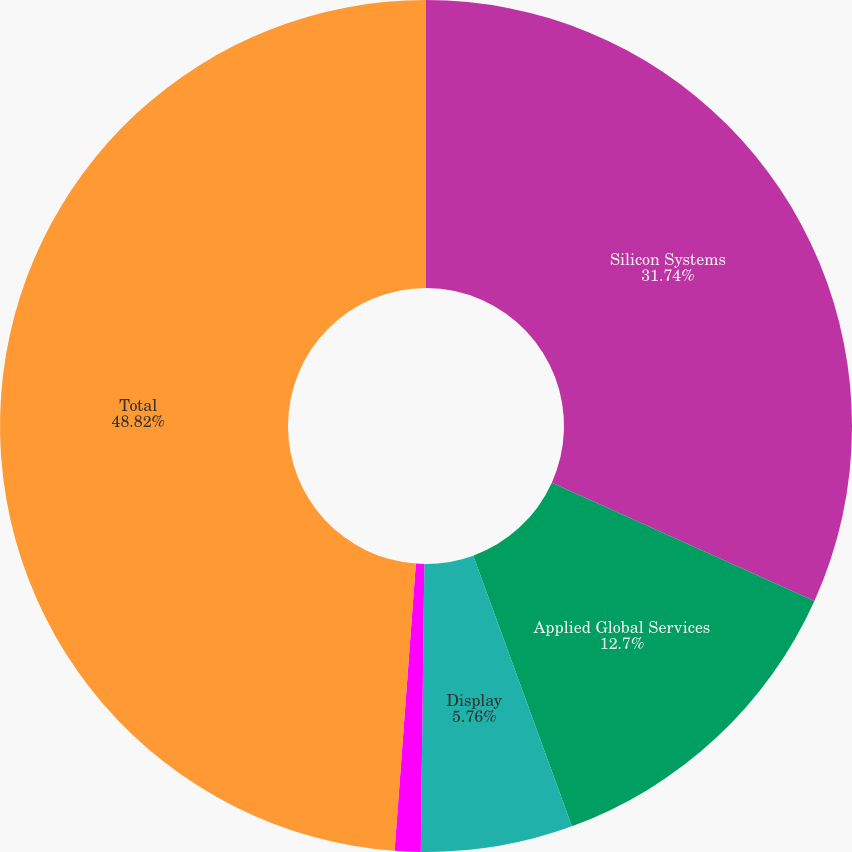Convert chart to OTSL. <chart><loc_0><loc_0><loc_500><loc_500><pie_chart><fcel>Silicon Systems<fcel>Applied Global Services<fcel>Display<fcel>Energy and Environmental<fcel>Total<nl><fcel>31.74%<fcel>12.7%<fcel>5.76%<fcel>0.98%<fcel>48.83%<nl></chart> 